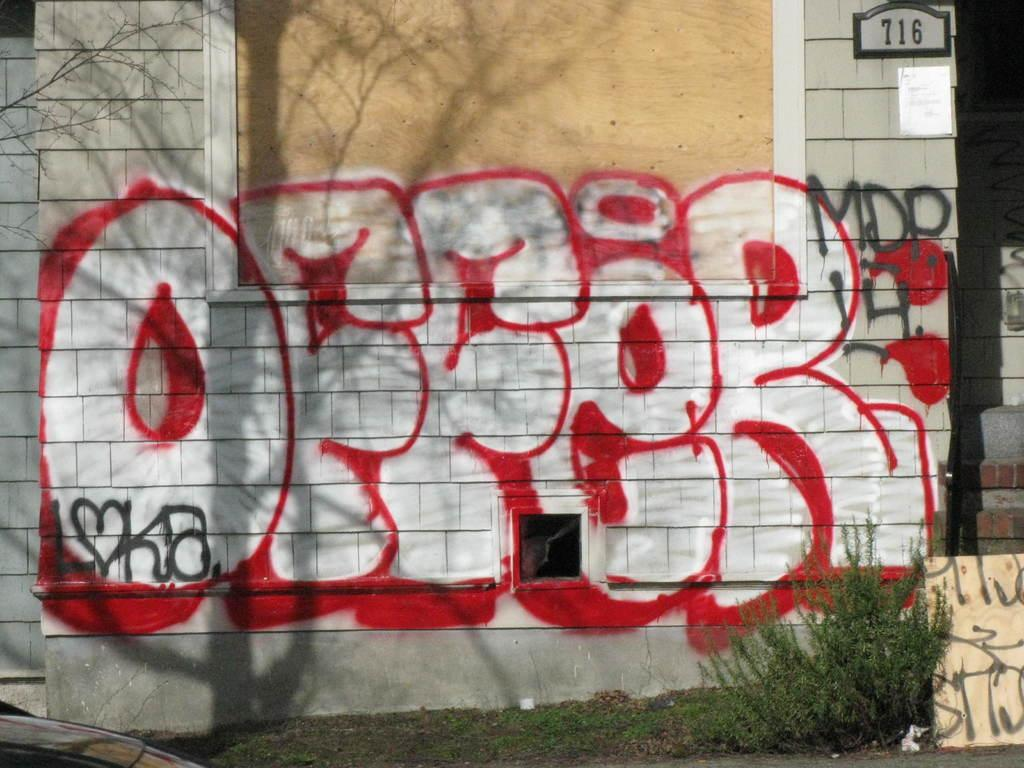What is the main feature of the building in the image? The building has graffiti paint in the image. Can you describe the surroundings of the building? There is a plant in a garden in front of the building. What type of string is used to hang the coat on the fan in the image? There is no string, coat, or fan present in the image. 